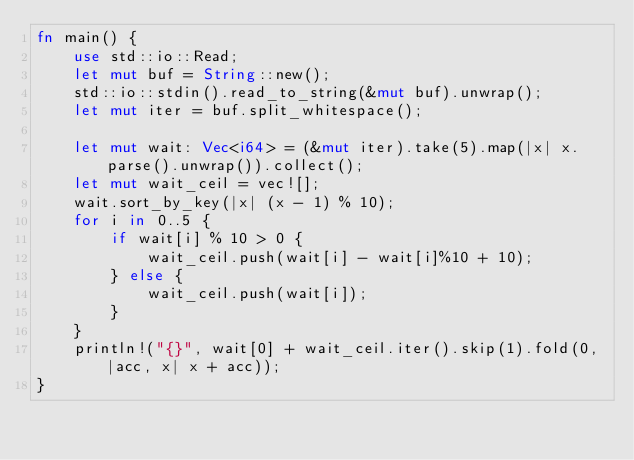Convert code to text. <code><loc_0><loc_0><loc_500><loc_500><_Rust_>fn main() {
    use std::io::Read;
    let mut buf = String::new();
    std::io::stdin().read_to_string(&mut buf).unwrap();
    let mut iter = buf.split_whitespace();
    
    let mut wait: Vec<i64> = (&mut iter).take(5).map(|x| x.parse().unwrap()).collect();
    let mut wait_ceil = vec![];
    wait.sort_by_key(|x| (x - 1) % 10);
    for i in 0..5 {
        if wait[i] % 10 > 0 {
            wait_ceil.push(wait[i] - wait[i]%10 + 10);
        } else {
            wait_ceil.push(wait[i]);
        }
    }
    println!("{}", wait[0] + wait_ceil.iter().skip(1).fold(0, |acc, x| x + acc));
}
</code> 